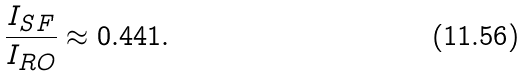<formula> <loc_0><loc_0><loc_500><loc_500>\frac { I _ { S F } } { I _ { R O } } \approx 0 . 4 4 1 .</formula> 